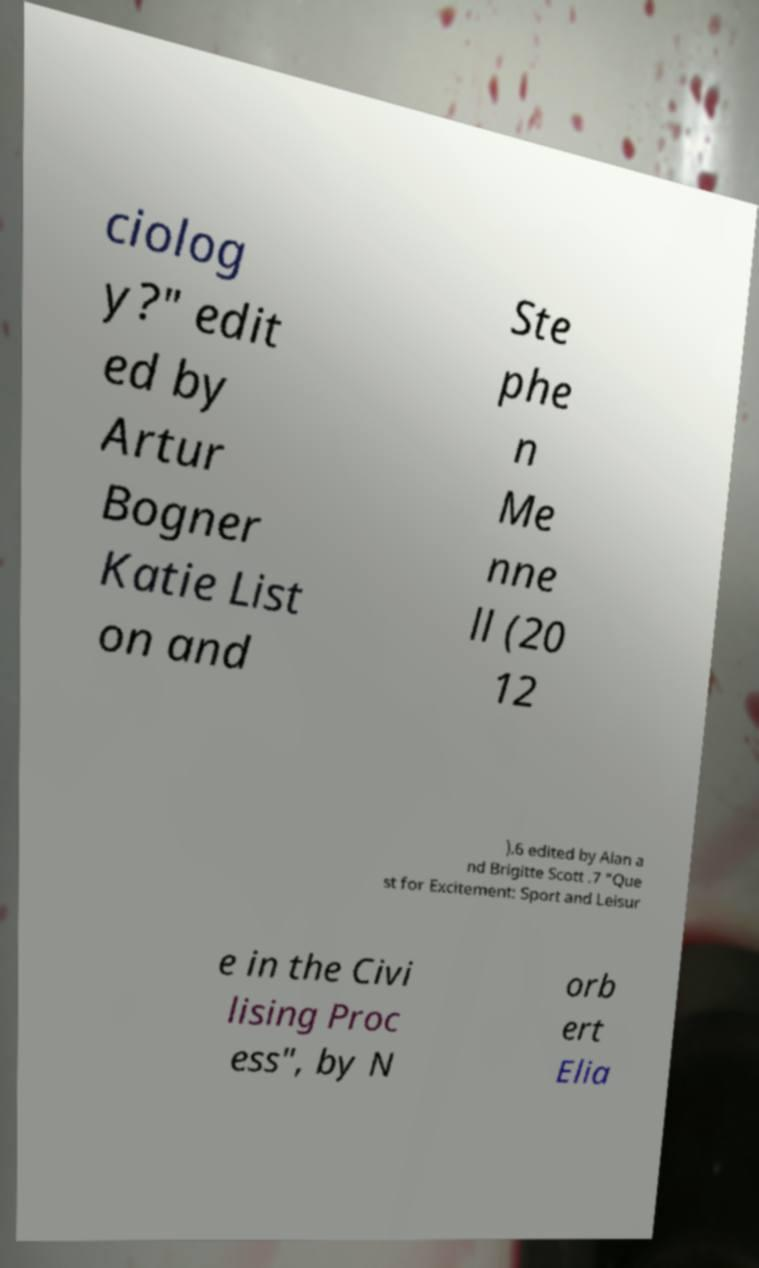Could you assist in decoding the text presented in this image and type it out clearly? ciolog y?" edit ed by Artur Bogner Katie List on and Ste phe n Me nne ll (20 12 ).6 edited by Alan a nd Brigitte Scott .7 "Que st for Excitement: Sport and Leisur e in the Civi lising Proc ess", by N orb ert Elia 